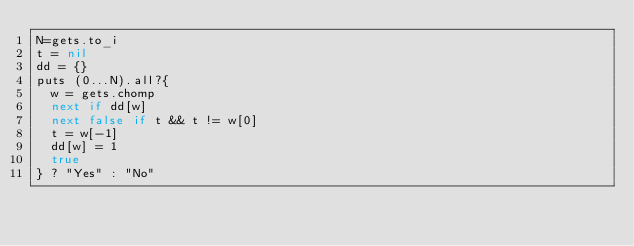<code> <loc_0><loc_0><loc_500><loc_500><_Ruby_>N=gets.to_i
t = nil
dd = {}
puts (0...N).all?{
  w = gets.chomp
  next if dd[w]
  next false if t && t != w[0]
  t = w[-1]
  dd[w] = 1
  true
} ? "Yes" : "No"</code> 